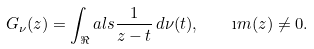<formula> <loc_0><loc_0><loc_500><loc_500>G _ { \nu } ( z ) = \int _ { \Re } a l s \frac { 1 } { z - t } \, d \nu ( t ) , \quad \i m ( z ) \neq 0 .</formula> 